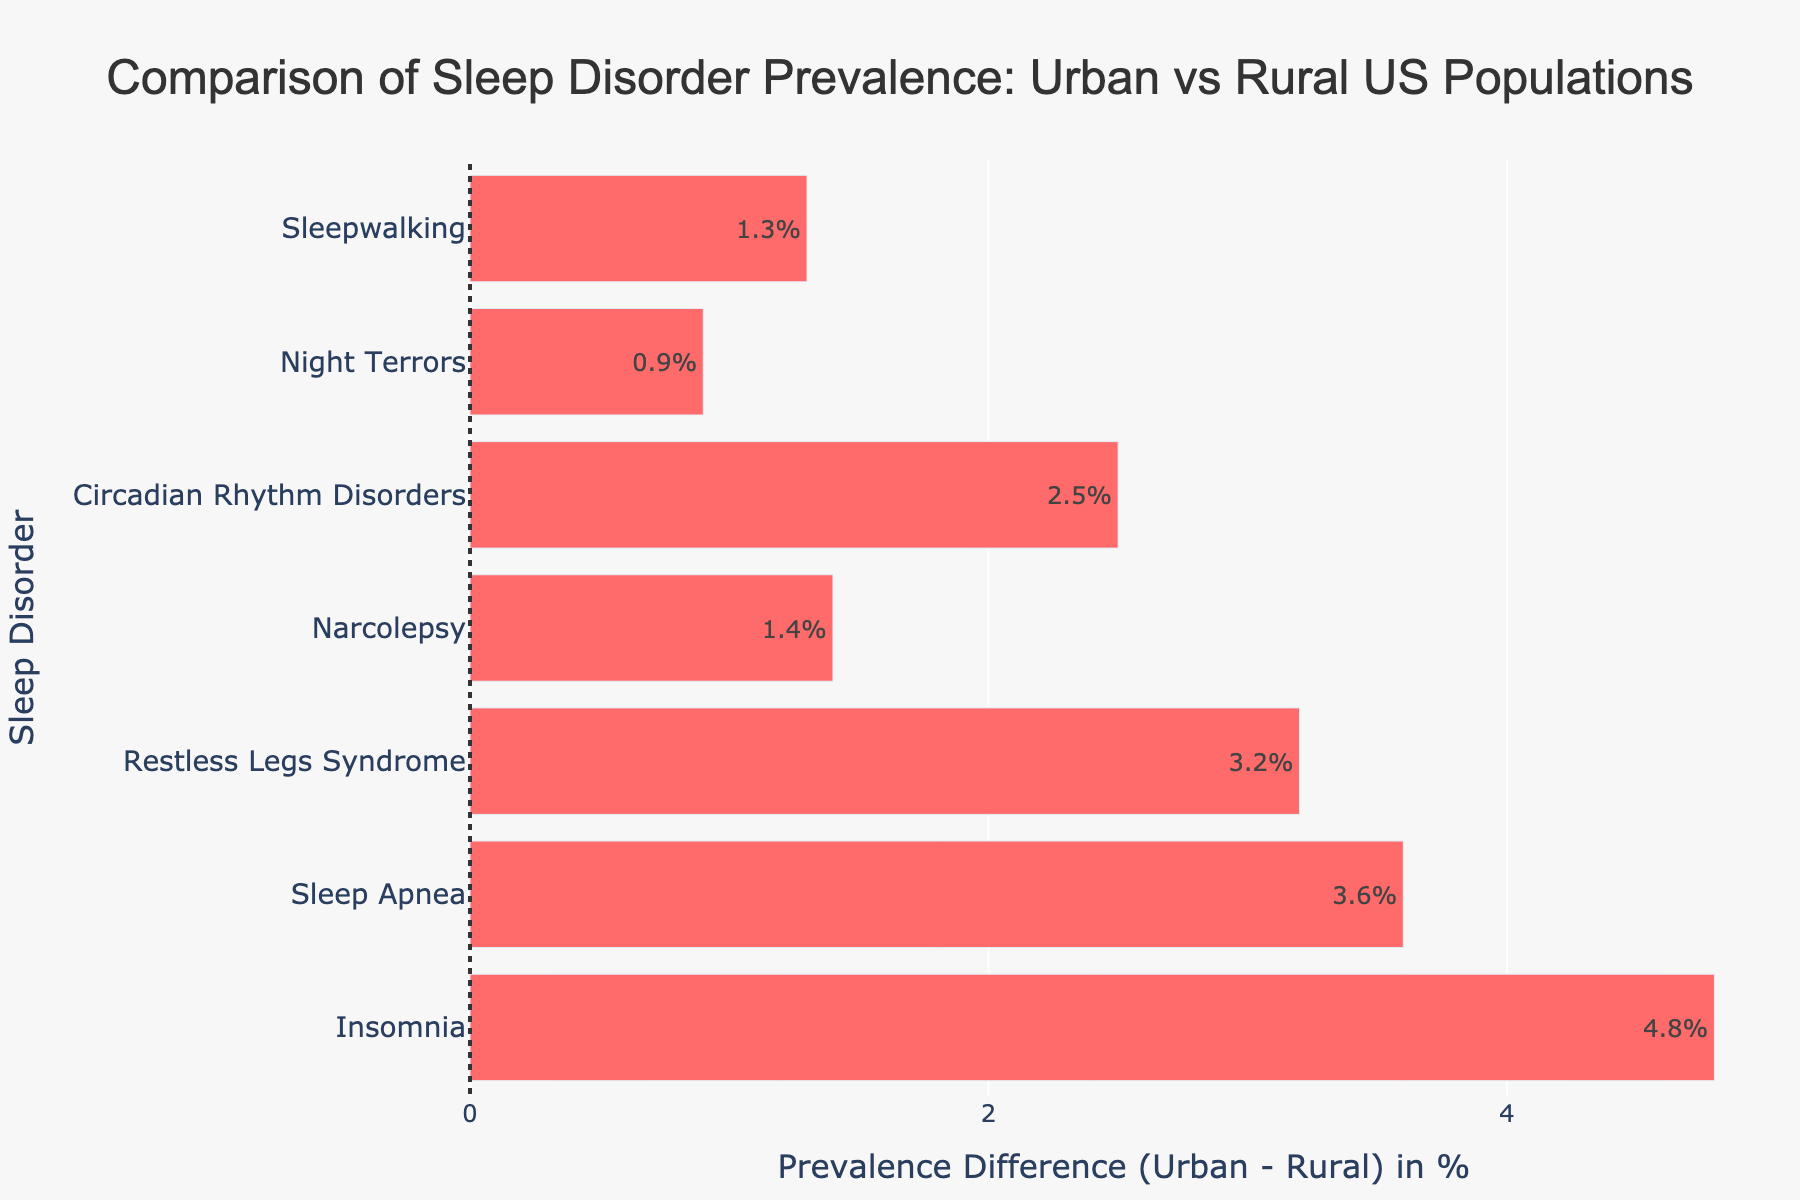Which sleep disorder has the largest prevalence difference between urban and rural populations? The difference is shown by the length of the bars. The longest bar corresponds to Sleep Apnea, with the difference of 3.6%
Answer: Sleep Apnea Which sleep disorder is more common in rural areas but less common in urban areas? All the bars are indicating urban values are higher than rural ones; there is no disorder more common in rural areas.
Answer: None What is the difference in prevalence for Narcolepsy between urban and rural populations? Look at the bar for Narcolepsy. The hover text provides the difference directly, showing 4.5% for urban and 3.1% for rural. The difference is 1.4%
Answer: 1.4% How much more prevalent is Insomnia in urban areas compared to rural areas? The difference can be calculated from the hover or bar text: 15.2% (urban) - 10.4% (rural) = 4.8%
Answer: 4.8% Sum up the differences in prevalence for Narcolepsy and Night Terrors. Calculate differences for Narcolepsy (1.4%) and Night Terrors (0.9%). Sum of these differences = 1.4% + 0.9% = 2.3%
Answer: 2.3% Which sleep disorder has the smallest prevalence difference between urban and rural populations? The smallest bar represents Night Terrors, with a difference of 0.9%
Answer: Night Terrors Compare Insomnia and Restless Legs Syndrome. Which one has a greater urban prevalence, and by how much? For Insomnia, urban prevalence is 15.2%. For Restless Legs Syndrome, it is 12.1%. The difference is 15.2% - 12.1% = 3.1%
Answer: Insomnia, by 3.1% Is Sleepwalking more prevalent in urban or rural populations, and what is the difference? Sleepwalking is more prevalent in urban areas as indicated by the positive bar (5.9% urban vs 4.6% rural). The difference is 5.9% - 4.6% = 1.3%
Answer: Urban, by 1.3% What are the three sleep disorders with the highest prevalence differences? By examining the lengths of the bars, the three disorders with the highest differences are Sleep Apnea (3.6%), Insomnia (4.8%), and Restless Legs Syndrome (3.2%)
Answer: Sleep Apnea, Insomnia, Restless Legs Syndrome 